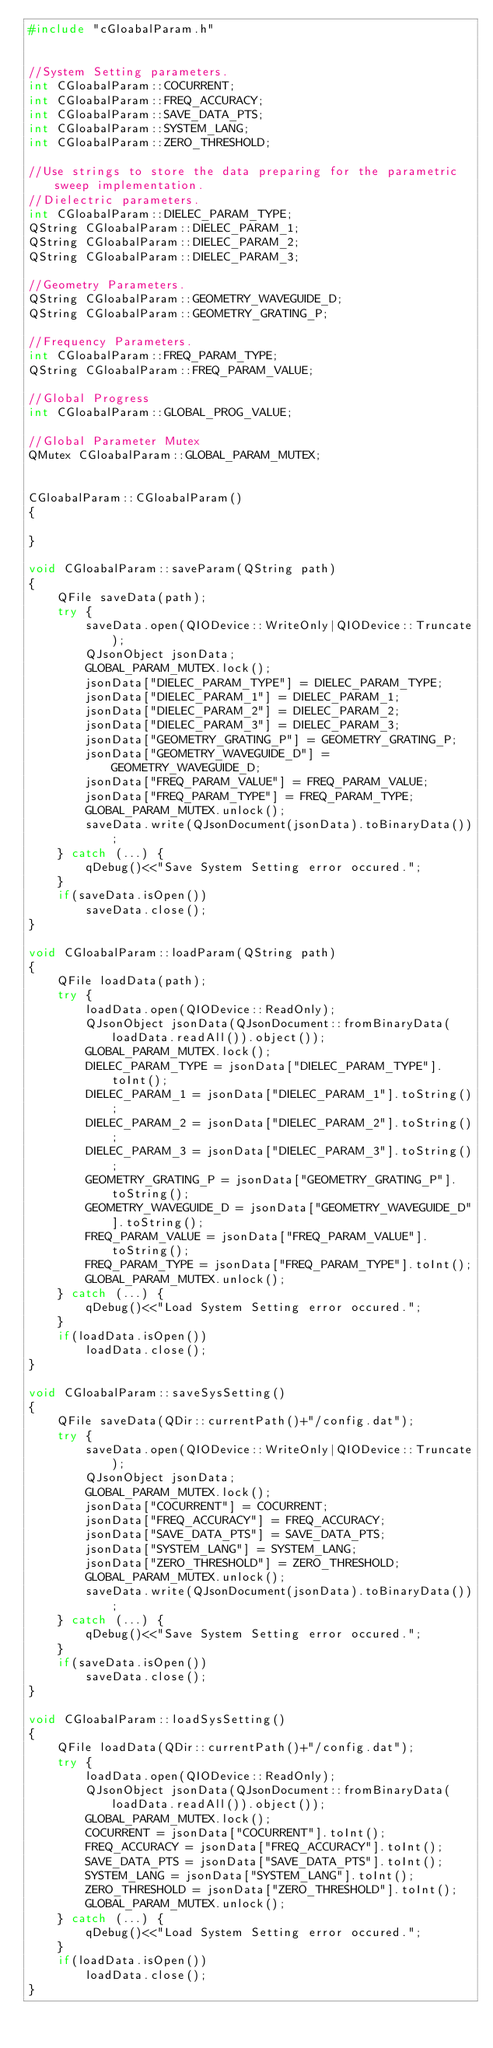Convert code to text. <code><loc_0><loc_0><loc_500><loc_500><_C++_>#include "cGloabalParam.h"


//System Setting parameters.
int CGloabalParam::COCURRENT;
int CGloabalParam::FREQ_ACCURACY;
int CGloabalParam::SAVE_DATA_PTS;
int CGloabalParam::SYSTEM_LANG;
int CGloabalParam::ZERO_THRESHOLD;

//Use strings to store the data preparing for the parametric sweep implementation.
//Dielectric parameters.
int CGloabalParam::DIELEC_PARAM_TYPE;
QString CGloabalParam::DIELEC_PARAM_1;
QString CGloabalParam::DIELEC_PARAM_2;
QString CGloabalParam::DIELEC_PARAM_3;

//Geometry Parameters.
QString CGloabalParam::GEOMETRY_WAVEGUIDE_D;
QString CGloabalParam::GEOMETRY_GRATING_P;

//Frequency Parameters.
int CGloabalParam::FREQ_PARAM_TYPE;
QString CGloabalParam::FREQ_PARAM_VALUE;

//Global Progress
int CGloabalParam::GLOBAL_PROG_VALUE;

//Global Parameter Mutex
QMutex CGloabalParam::GLOBAL_PARAM_MUTEX;


CGloabalParam::CGloabalParam()
{

}

void CGloabalParam::saveParam(QString path)
{
    QFile saveData(path);
    try {
        saveData.open(QIODevice::WriteOnly|QIODevice::Truncate);
        QJsonObject jsonData;
        GLOBAL_PARAM_MUTEX.lock();
        jsonData["DIELEC_PARAM_TYPE"] = DIELEC_PARAM_TYPE;
        jsonData["DIELEC_PARAM_1"] = DIELEC_PARAM_1;
        jsonData["DIELEC_PARAM_2"] = DIELEC_PARAM_2;
        jsonData["DIELEC_PARAM_3"] = DIELEC_PARAM_3;
        jsonData["GEOMETRY_GRATING_P"] = GEOMETRY_GRATING_P;
        jsonData["GEOMETRY_WAVEGUIDE_D"] = GEOMETRY_WAVEGUIDE_D;
        jsonData["FREQ_PARAM_VALUE"] = FREQ_PARAM_VALUE;
        jsonData["FREQ_PARAM_TYPE"] = FREQ_PARAM_TYPE;
        GLOBAL_PARAM_MUTEX.unlock();
        saveData.write(QJsonDocument(jsonData).toBinaryData());
    } catch (...) {
        qDebug()<<"Save System Setting error occured.";
    }
    if(saveData.isOpen())
        saveData.close();
}

void CGloabalParam::loadParam(QString path)
{
    QFile loadData(path);
    try {
        loadData.open(QIODevice::ReadOnly);
        QJsonObject jsonData(QJsonDocument::fromBinaryData(loadData.readAll()).object());
        GLOBAL_PARAM_MUTEX.lock();
        DIELEC_PARAM_TYPE = jsonData["DIELEC_PARAM_TYPE"].toInt();
        DIELEC_PARAM_1 = jsonData["DIELEC_PARAM_1"].toString();
        DIELEC_PARAM_2 = jsonData["DIELEC_PARAM_2"].toString();
        DIELEC_PARAM_3 = jsonData["DIELEC_PARAM_3"].toString();
        GEOMETRY_GRATING_P = jsonData["GEOMETRY_GRATING_P"].toString();
        GEOMETRY_WAVEGUIDE_D = jsonData["GEOMETRY_WAVEGUIDE_D"].toString();
        FREQ_PARAM_VALUE = jsonData["FREQ_PARAM_VALUE"].toString();
        FREQ_PARAM_TYPE = jsonData["FREQ_PARAM_TYPE"].toInt();
        GLOBAL_PARAM_MUTEX.unlock();
    } catch (...) {
        qDebug()<<"Load System Setting error occured.";
    }
    if(loadData.isOpen())
        loadData.close();
}

void CGloabalParam::saveSysSetting()
{
    QFile saveData(QDir::currentPath()+"/config.dat");
    try {
        saveData.open(QIODevice::WriteOnly|QIODevice::Truncate);
        QJsonObject jsonData;
        GLOBAL_PARAM_MUTEX.lock();
        jsonData["COCURRENT"] = COCURRENT;
        jsonData["FREQ_ACCURACY"] = FREQ_ACCURACY;
        jsonData["SAVE_DATA_PTS"] = SAVE_DATA_PTS;
        jsonData["SYSTEM_LANG"] = SYSTEM_LANG;
        jsonData["ZERO_THRESHOLD"] = ZERO_THRESHOLD;
        GLOBAL_PARAM_MUTEX.unlock();
        saveData.write(QJsonDocument(jsonData).toBinaryData());
    } catch (...) {
        qDebug()<<"Save System Setting error occured.";
    }
    if(saveData.isOpen())
        saveData.close();
}

void CGloabalParam::loadSysSetting()
{
    QFile loadData(QDir::currentPath()+"/config.dat");
    try {
        loadData.open(QIODevice::ReadOnly);
        QJsonObject jsonData(QJsonDocument::fromBinaryData(loadData.readAll()).object());
        GLOBAL_PARAM_MUTEX.lock();
        COCURRENT = jsonData["COCURRENT"].toInt();
        FREQ_ACCURACY = jsonData["FREQ_ACCURACY"].toInt();
        SAVE_DATA_PTS = jsonData["SAVE_DATA_PTS"].toInt();
        SYSTEM_LANG = jsonData["SYSTEM_LANG"].toInt();
        ZERO_THRESHOLD = jsonData["ZERO_THRESHOLD"].toInt();
        GLOBAL_PARAM_MUTEX.unlock();
    } catch (...) {
        qDebug()<<"Load System Setting error occured.";
    }
    if(loadData.isOpen())
        loadData.close();
}
</code> 